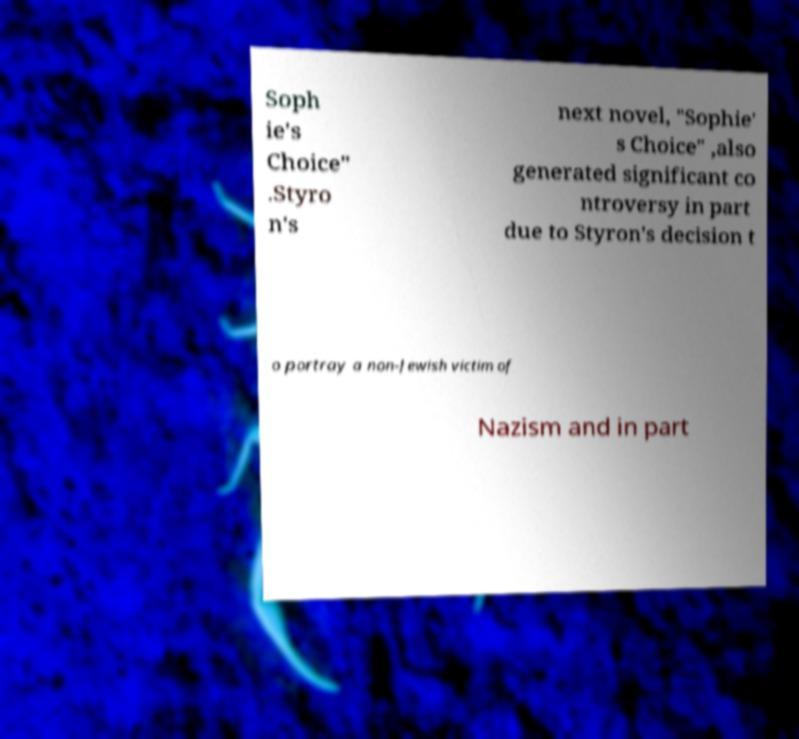I need the written content from this picture converted into text. Can you do that? Soph ie's Choice" .Styro n's next novel, "Sophie' s Choice" ,also generated significant co ntroversy in part due to Styron's decision t o portray a non-Jewish victim of Nazism and in part 